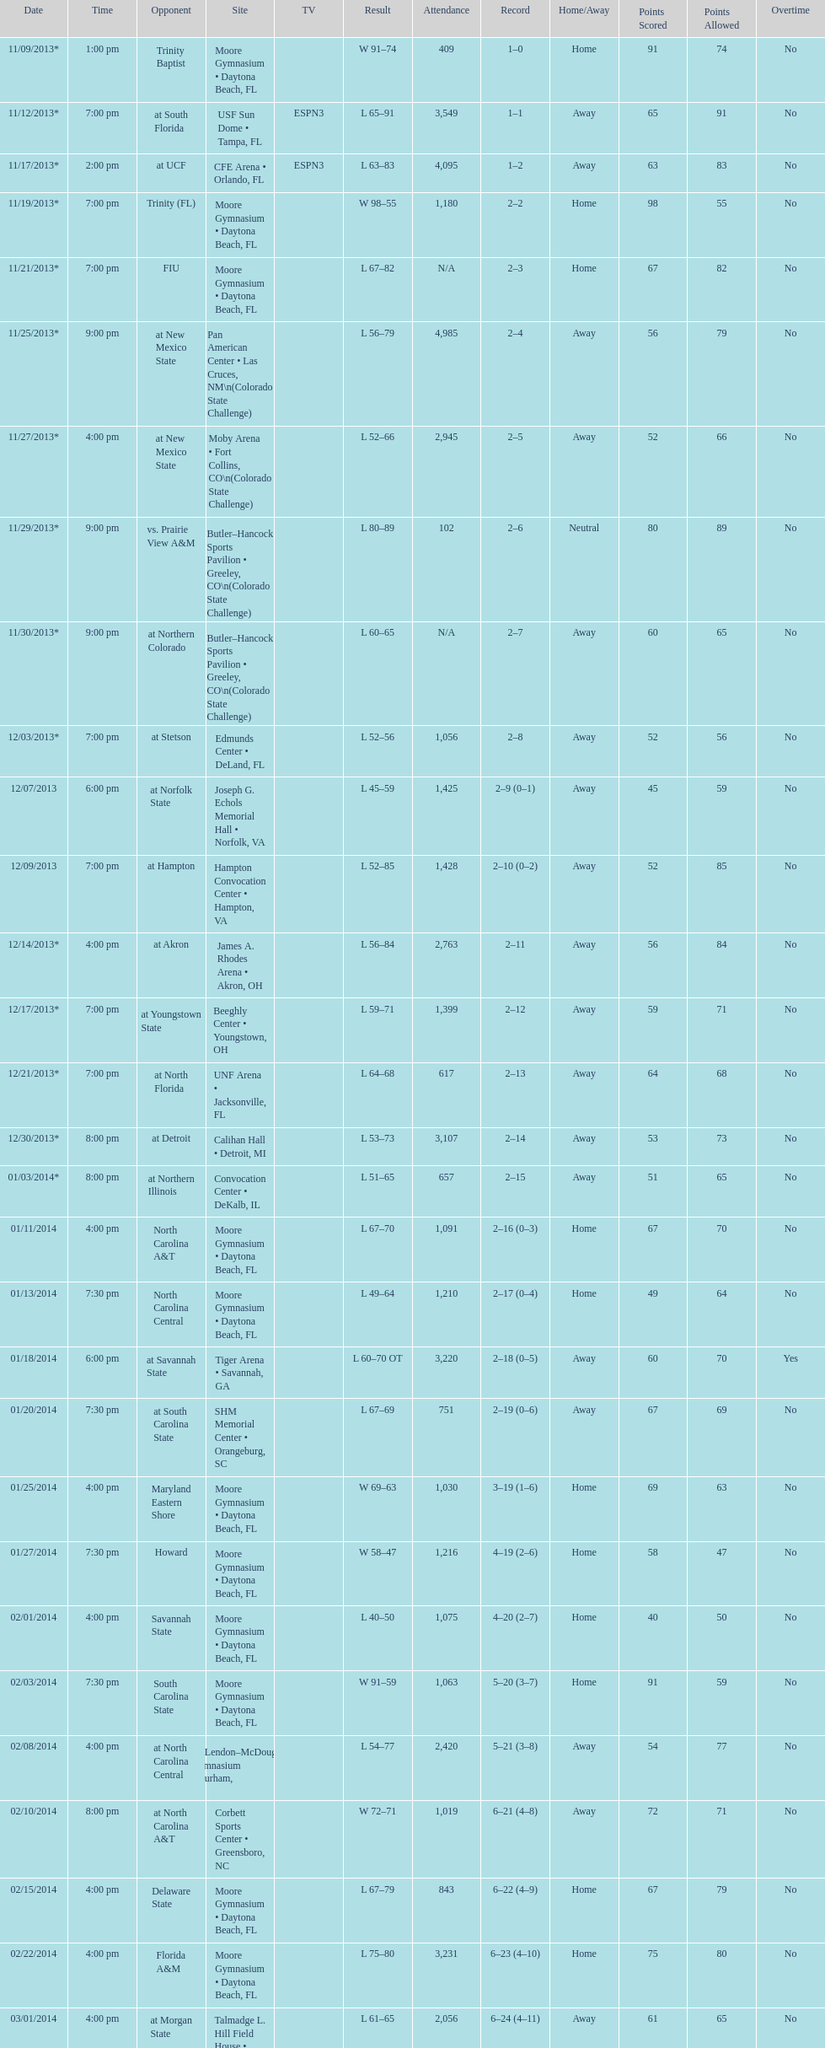Was the attendance of the game held on 11/19/2013 greater than 1,000? Yes. 